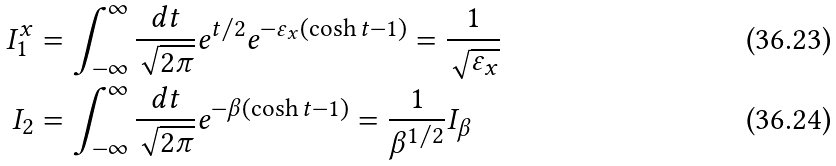<formula> <loc_0><loc_0><loc_500><loc_500>I ^ { x } _ { 1 } & = \int _ { - \infty } ^ { \infty } \frac { d t } { \sqrt { 2 \pi } } e ^ { t / 2 } e ^ { - \varepsilon _ { x } ( \cosh t - 1 ) } = \frac { 1 } { \sqrt { \varepsilon _ { x } } } \\ I _ { 2 } & = \int _ { - \infty } ^ { \infty } \frac { d t } { \sqrt { 2 \pi } } e ^ { - \beta ( \cosh t - 1 ) } = \frac { 1 } { \beta ^ { 1 / 2 } } I _ { \beta } \</formula> 